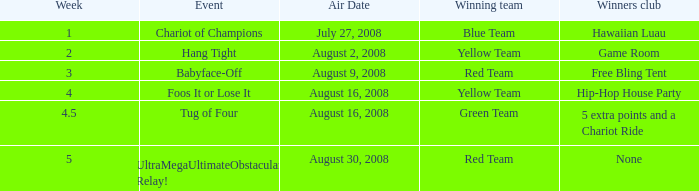Which Week has an Air Date of august 2, 2008? 2.0. 